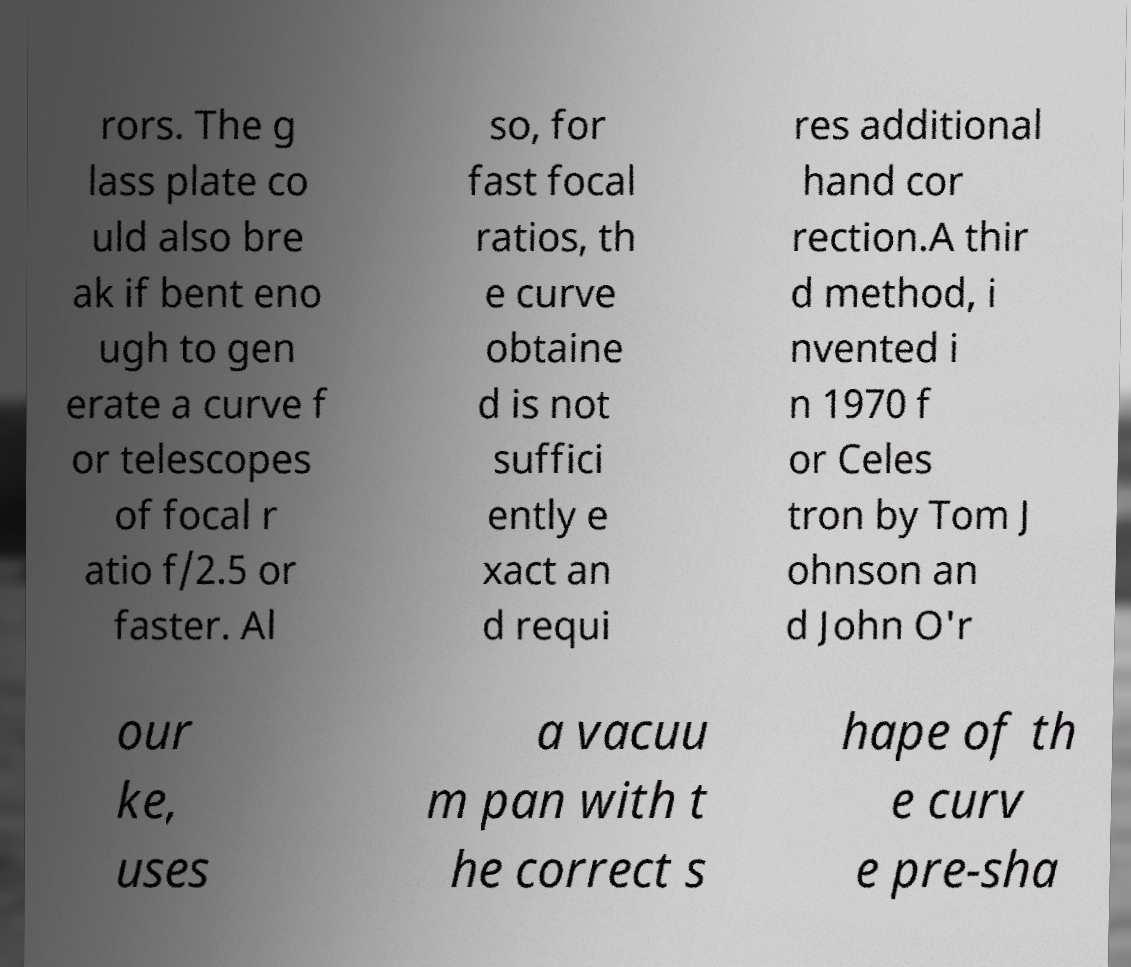Can you accurately transcribe the text from the provided image for me? rors. The g lass plate co uld also bre ak if bent eno ugh to gen erate a curve f or telescopes of focal r atio f/2.5 or faster. Al so, for fast focal ratios, th e curve obtaine d is not suffici ently e xact an d requi res additional hand cor rection.A thir d method, i nvented i n 1970 f or Celes tron by Tom J ohnson an d John O'r our ke, uses a vacuu m pan with t he correct s hape of th e curv e pre-sha 